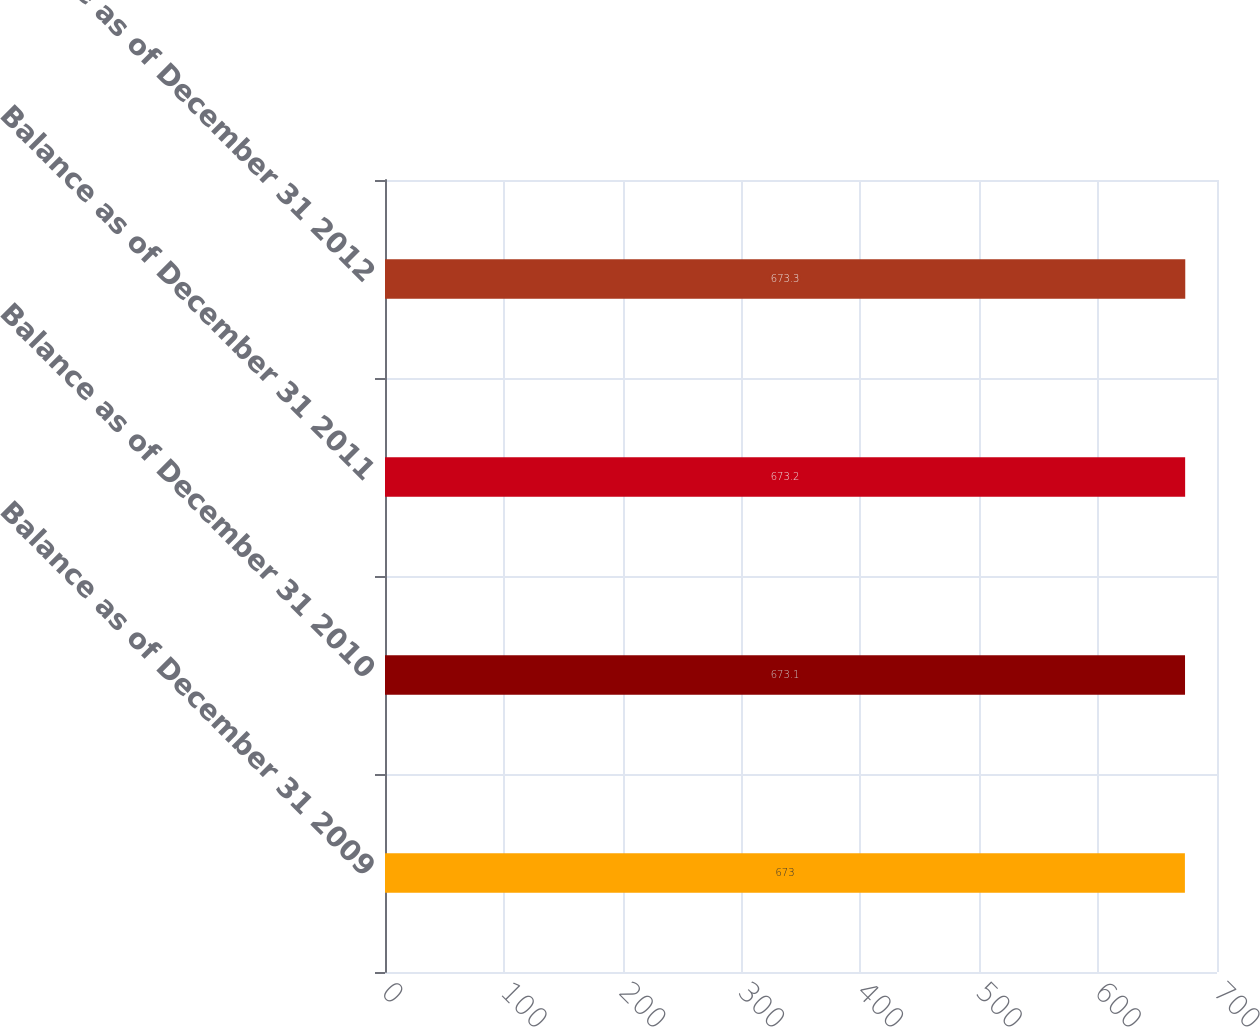Convert chart to OTSL. <chart><loc_0><loc_0><loc_500><loc_500><bar_chart><fcel>Balance as of December 31 2009<fcel>Balance as of December 31 2010<fcel>Balance as of December 31 2011<fcel>Balance as of December 31 2012<nl><fcel>673<fcel>673.1<fcel>673.2<fcel>673.3<nl></chart> 